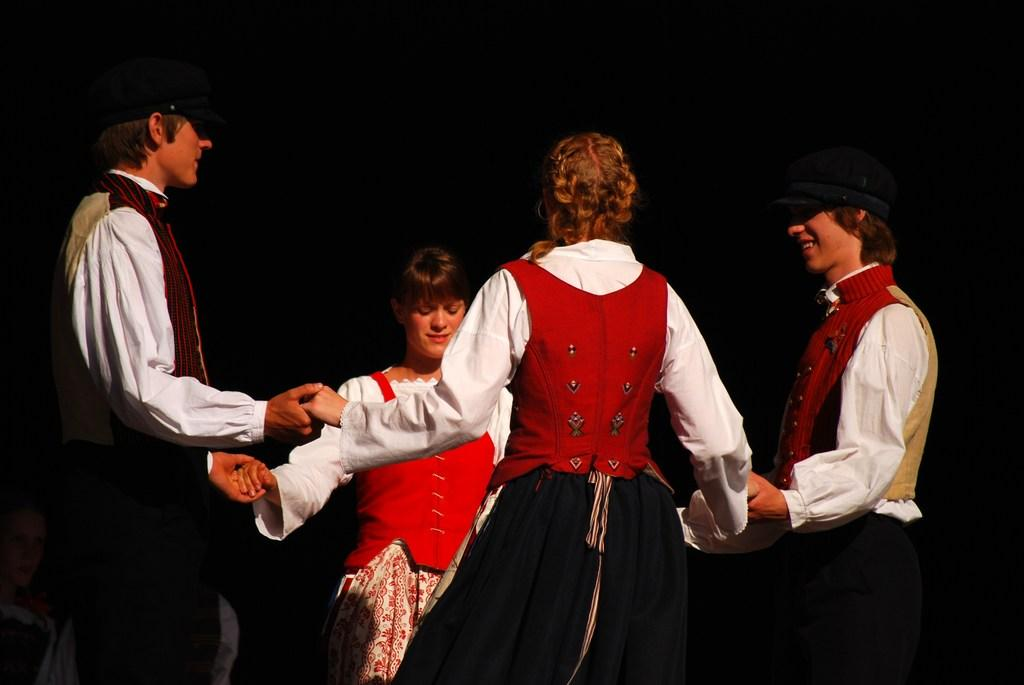How many people are in the image? There are four persons in the image. What are the people doing in the image? The four persons are standing and holding each other's hands. Where is the person located in the image? There is a person at the bottom left side of the image. What can be observed about the background of the image? The background of the image is dark. What type of street is visible in the image? There is no street present in the image; it features four persons holding hands with a dark background. How many bananas are being held by the person at the bottom left side of the image? There are no bananas visible in the image. 